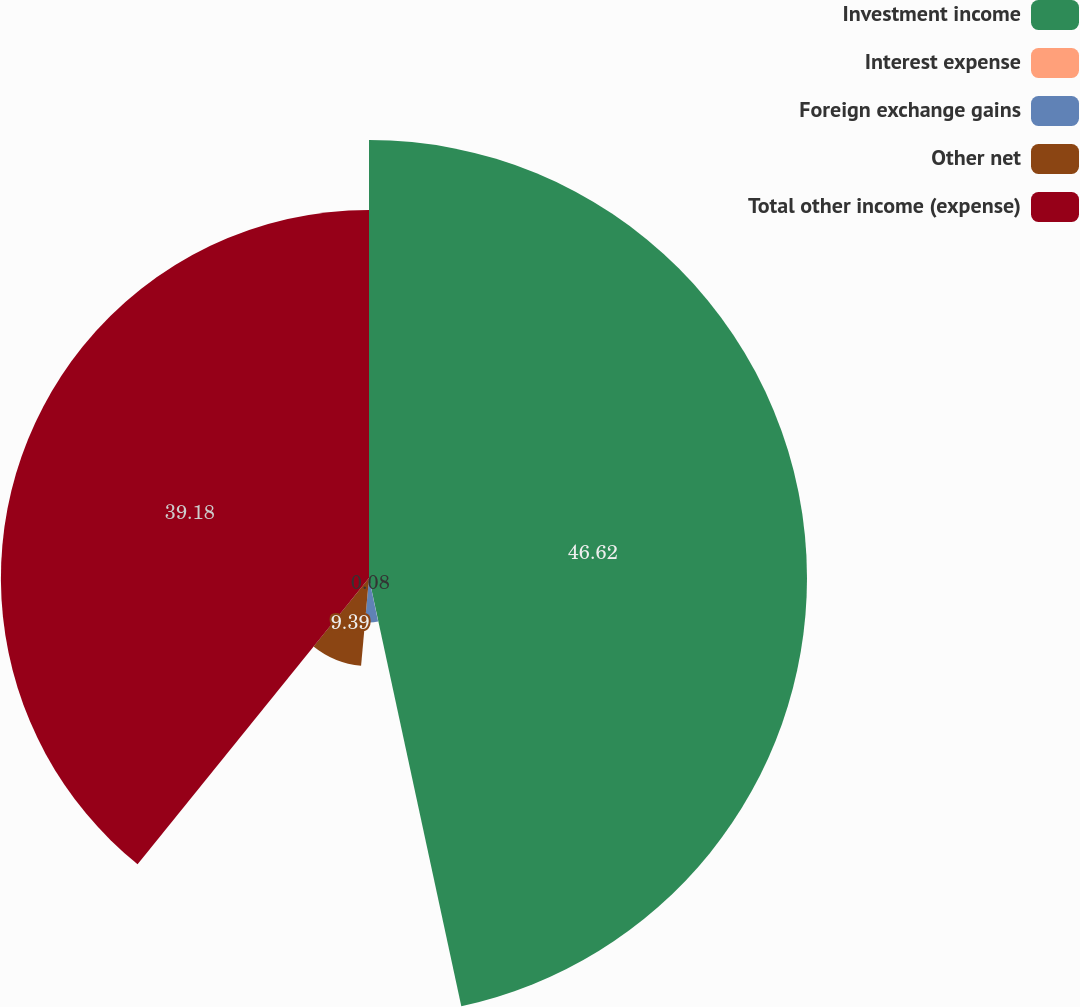Convert chart to OTSL. <chart><loc_0><loc_0><loc_500><loc_500><pie_chart><fcel>Investment income<fcel>Interest expense<fcel>Foreign exchange gains<fcel>Other net<fcel>Total other income (expense)<nl><fcel>46.62%<fcel>0.08%<fcel>4.73%<fcel>9.39%<fcel>39.18%<nl></chart> 